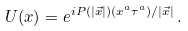Convert formula to latex. <formula><loc_0><loc_0><loc_500><loc_500>U ( x ) = e ^ { i P ( | { \vec { x } } | ) ( x ^ { a } \tau ^ { a } ) / | { \vec { x } } | } \, .</formula> 